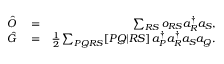<formula> <loc_0><loc_0><loc_500><loc_500>\begin{array} { r l r } { \hat { O } } & = } & { \sum _ { R S } o _ { R S } a _ { R } ^ { \dagger } a _ { S } , } \\ { \hat { G } } & = } & { \frac { 1 } { 2 } \sum _ { P Q R S } [ P Q | R S ] \, a _ { P } ^ { \dagger } a _ { R } ^ { \dagger } a _ { S } a _ { Q } . } \end{array}</formula> 